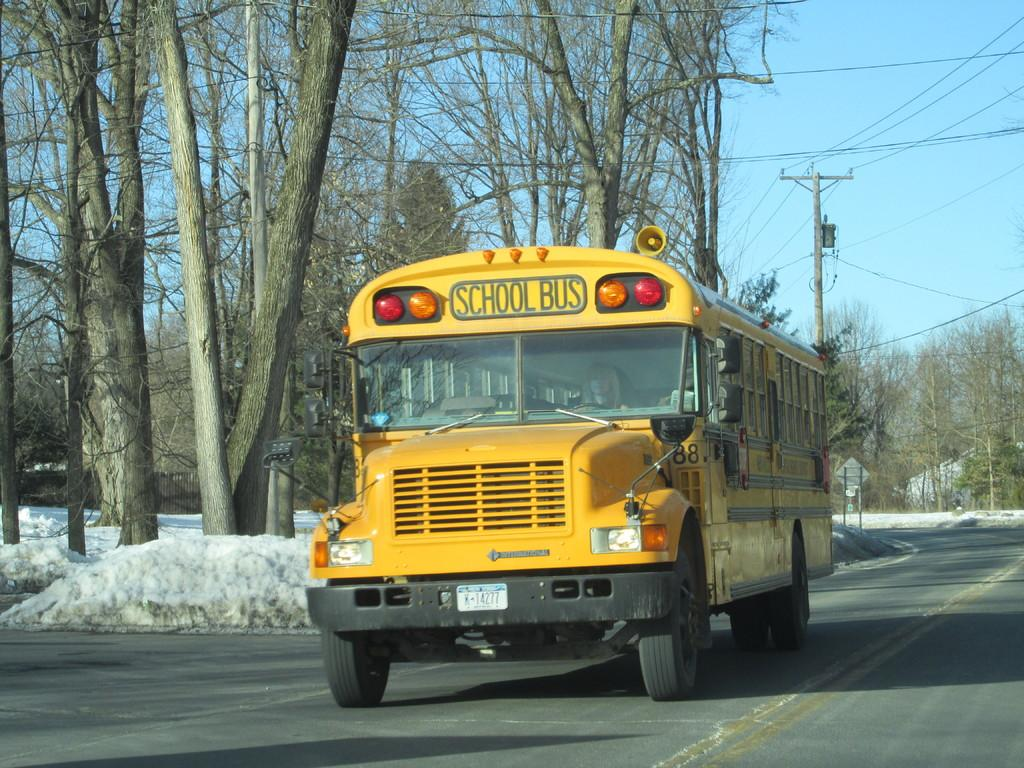<image>
Give a short and clear explanation of the subsequent image. School bus is riding on a road in a cold snowy city 